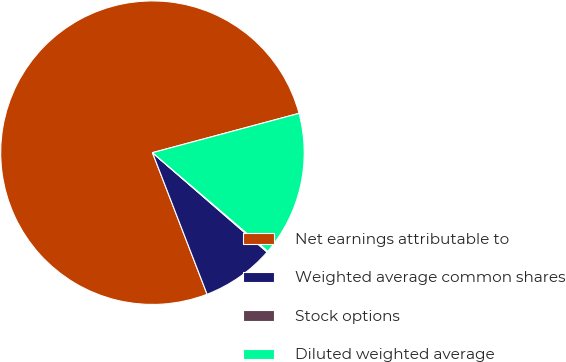Convert chart. <chart><loc_0><loc_0><loc_500><loc_500><pie_chart><fcel>Net earnings attributable to<fcel>Weighted average common shares<fcel>Stock options<fcel>Diluted weighted average<nl><fcel>76.69%<fcel>7.77%<fcel>0.11%<fcel>15.43%<nl></chart> 